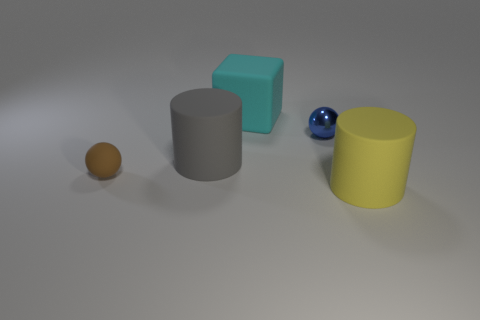Add 2 tiny cyan things. How many objects exist? 7 Add 2 large matte things. How many large matte things exist? 5 Subtract 0 gray spheres. How many objects are left? 5 Subtract all cylinders. How many objects are left? 3 Subtract all green cylinders. Subtract all green blocks. How many cylinders are left? 2 Subtract all cubes. Subtract all big yellow objects. How many objects are left? 3 Add 1 small brown balls. How many small brown balls are left? 2 